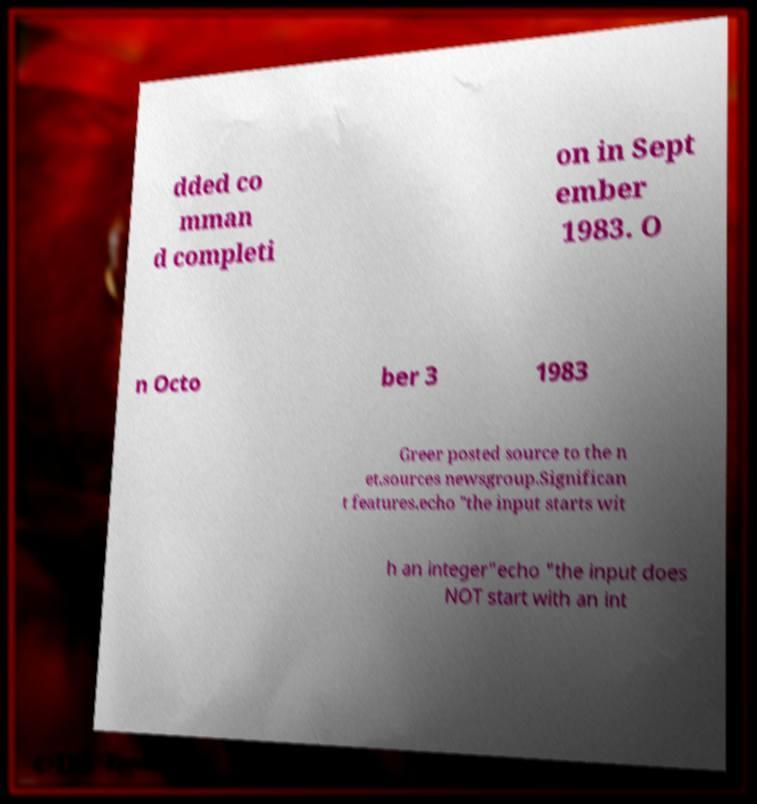Please read and relay the text visible in this image. What does it say? dded co mman d completi on in Sept ember 1983. O n Octo ber 3 1983 Greer posted source to the n et.sources newsgroup.Significan t features.echo "the input starts wit h an integer"echo "the input does NOT start with an int 